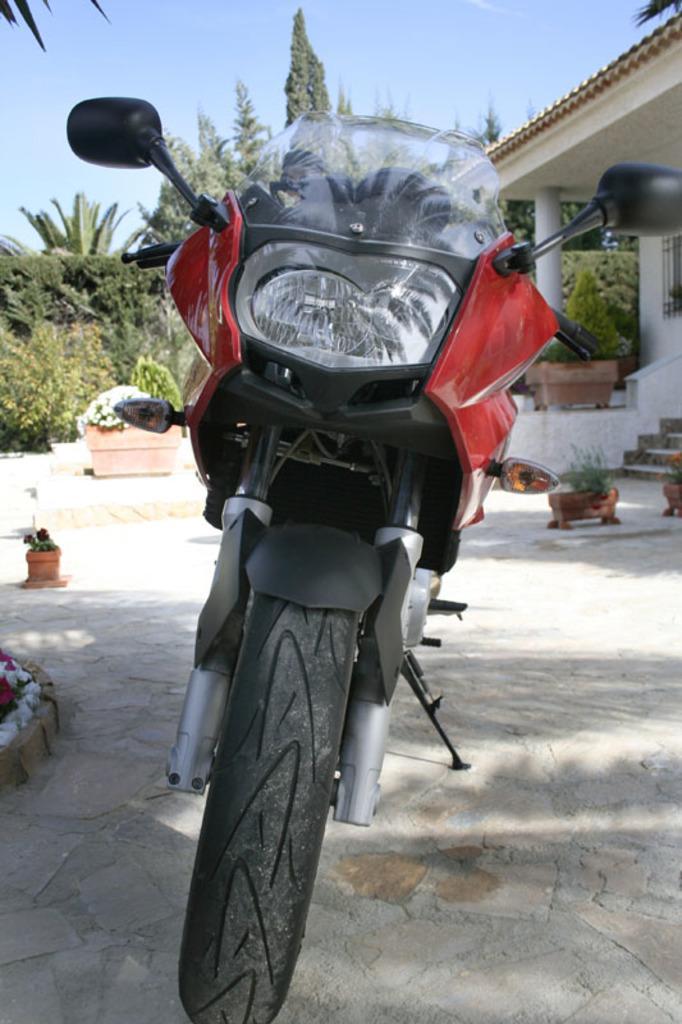Describe this image in one or two sentences. In this image, at the middle there is a red and black color bike, there are two black color side mirrors on the bike, at the background there are some green color plants and trees, at the top there is a blue color sky. 